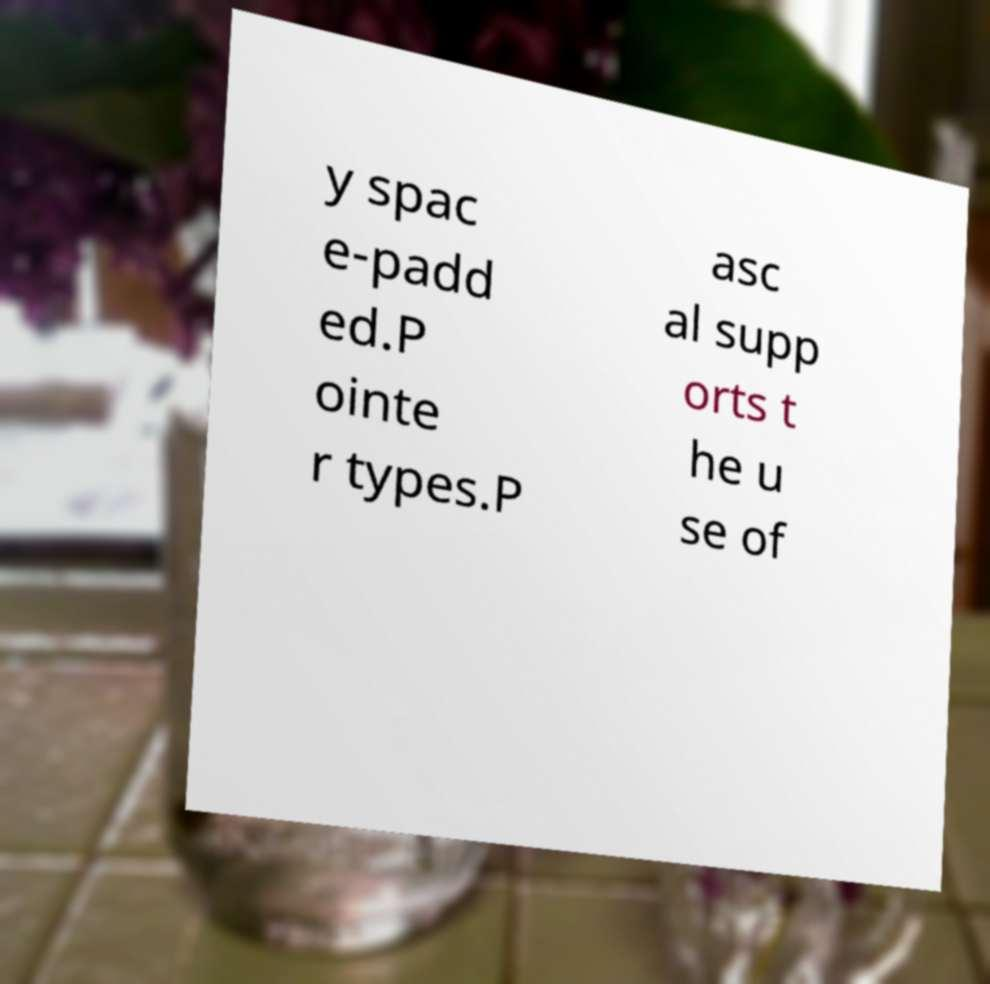Please identify and transcribe the text found in this image. y spac e-padd ed.P ointe r types.P asc al supp orts t he u se of 